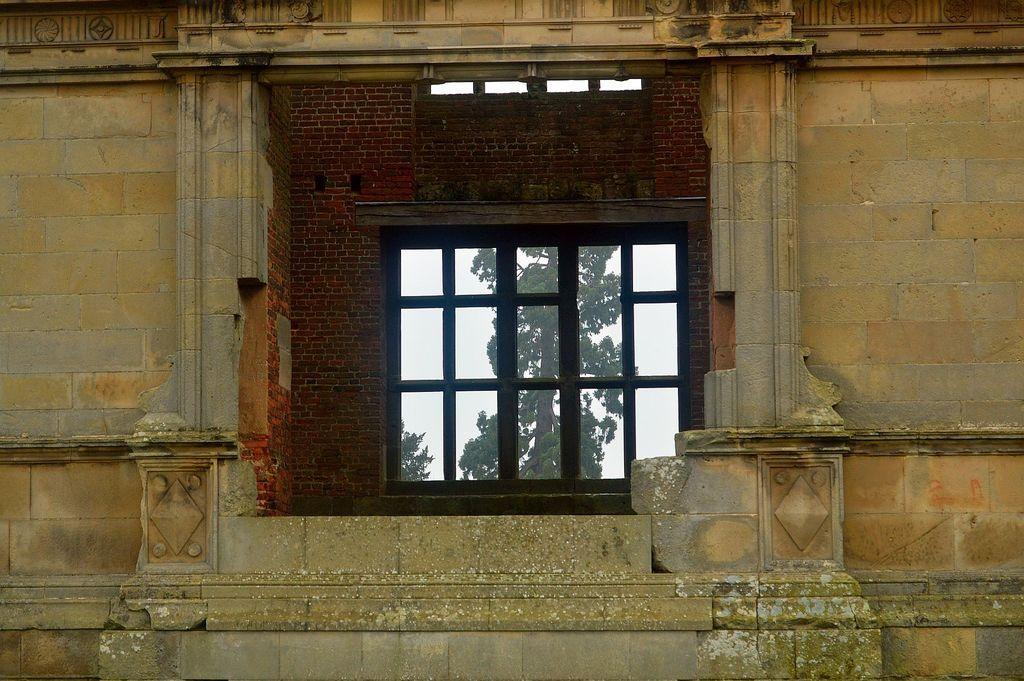Could you give a brief overview of what you see in this image? In the center of the picture there is a window and there is a brick wall. In the foreground of the picture there is a building. 